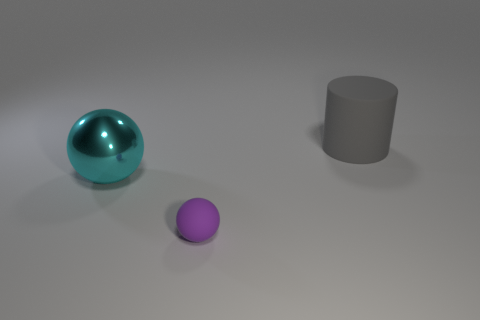Add 2 tiny brown balls. How many objects exist? 5 Subtract all spheres. How many objects are left? 1 Add 2 big shiny things. How many big shiny things exist? 3 Subtract 0 blue blocks. How many objects are left? 3 Subtract all large matte things. Subtract all large gray rubber cylinders. How many objects are left? 1 Add 3 large cyan metallic things. How many large cyan metallic things are left? 4 